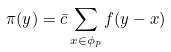Convert formula to latex. <formula><loc_0><loc_0><loc_500><loc_500>\pi ( y ) = \bar { c } \sum _ { x \in \phi _ { p } } f ( y - x )</formula> 